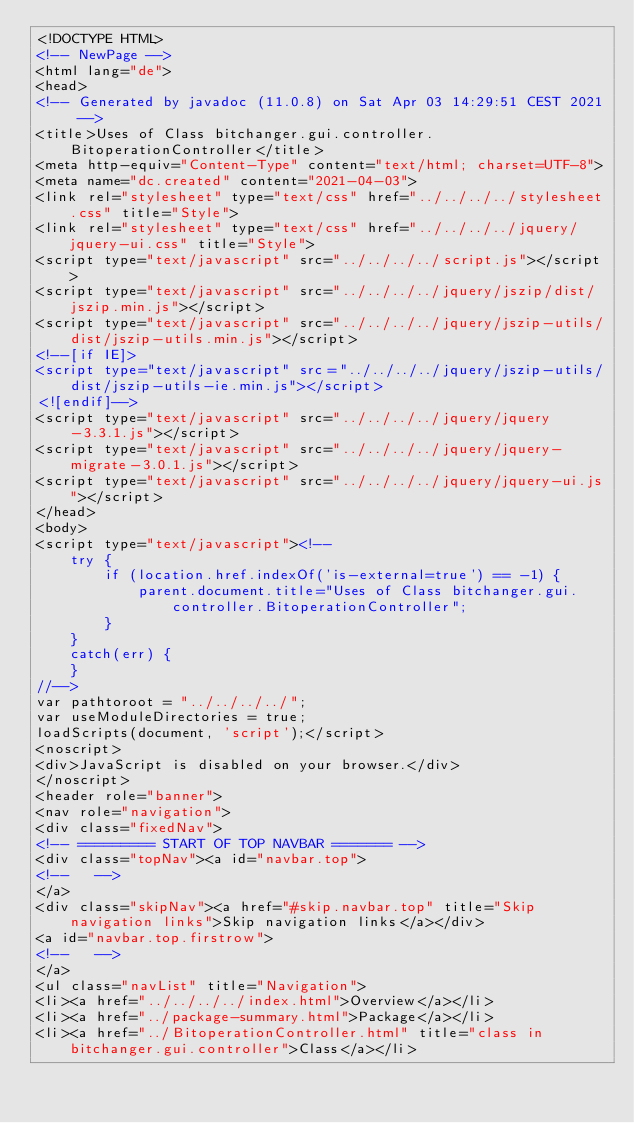Convert code to text. <code><loc_0><loc_0><loc_500><loc_500><_HTML_><!DOCTYPE HTML>
<!-- NewPage -->
<html lang="de">
<head>
<!-- Generated by javadoc (11.0.8) on Sat Apr 03 14:29:51 CEST 2021 -->
<title>Uses of Class bitchanger.gui.controller.BitoperationController</title>
<meta http-equiv="Content-Type" content="text/html; charset=UTF-8">
<meta name="dc.created" content="2021-04-03">
<link rel="stylesheet" type="text/css" href="../../../../stylesheet.css" title="Style">
<link rel="stylesheet" type="text/css" href="../../../../jquery/jquery-ui.css" title="Style">
<script type="text/javascript" src="../../../../script.js"></script>
<script type="text/javascript" src="../../../../jquery/jszip/dist/jszip.min.js"></script>
<script type="text/javascript" src="../../../../jquery/jszip-utils/dist/jszip-utils.min.js"></script>
<!--[if IE]>
<script type="text/javascript" src="../../../../jquery/jszip-utils/dist/jszip-utils-ie.min.js"></script>
<![endif]-->
<script type="text/javascript" src="../../../../jquery/jquery-3.3.1.js"></script>
<script type="text/javascript" src="../../../../jquery/jquery-migrate-3.0.1.js"></script>
<script type="text/javascript" src="../../../../jquery/jquery-ui.js"></script>
</head>
<body>
<script type="text/javascript"><!--
    try {
        if (location.href.indexOf('is-external=true') == -1) {
            parent.document.title="Uses of Class bitchanger.gui.controller.BitoperationController";
        }
    }
    catch(err) {
    }
//-->
var pathtoroot = "../../../../";
var useModuleDirectories = true;
loadScripts(document, 'script');</script>
<noscript>
<div>JavaScript is disabled on your browser.</div>
</noscript>
<header role="banner">
<nav role="navigation">
<div class="fixedNav">
<!-- ========= START OF TOP NAVBAR ======= -->
<div class="topNav"><a id="navbar.top">
<!--   -->
</a>
<div class="skipNav"><a href="#skip.navbar.top" title="Skip navigation links">Skip navigation links</a></div>
<a id="navbar.top.firstrow">
<!--   -->
</a>
<ul class="navList" title="Navigation">
<li><a href="../../../../index.html">Overview</a></li>
<li><a href="../package-summary.html">Package</a></li>
<li><a href="../BitoperationController.html" title="class in bitchanger.gui.controller">Class</a></li></code> 